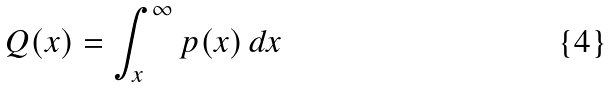<formula> <loc_0><loc_0><loc_500><loc_500>Q ( x ) = \int _ { x } ^ { \infty } p ( x ) \, d x</formula> 